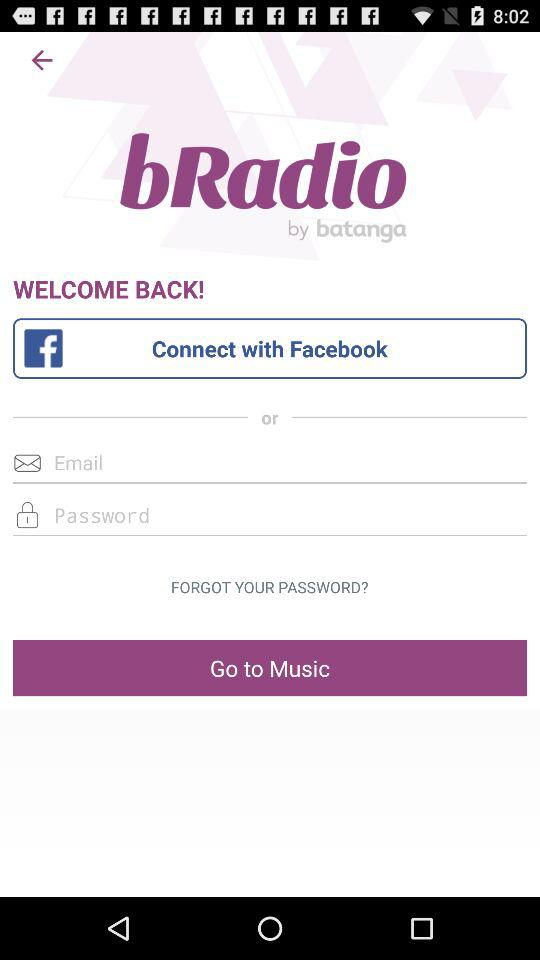What is the application name? The application name is "bRadio". 